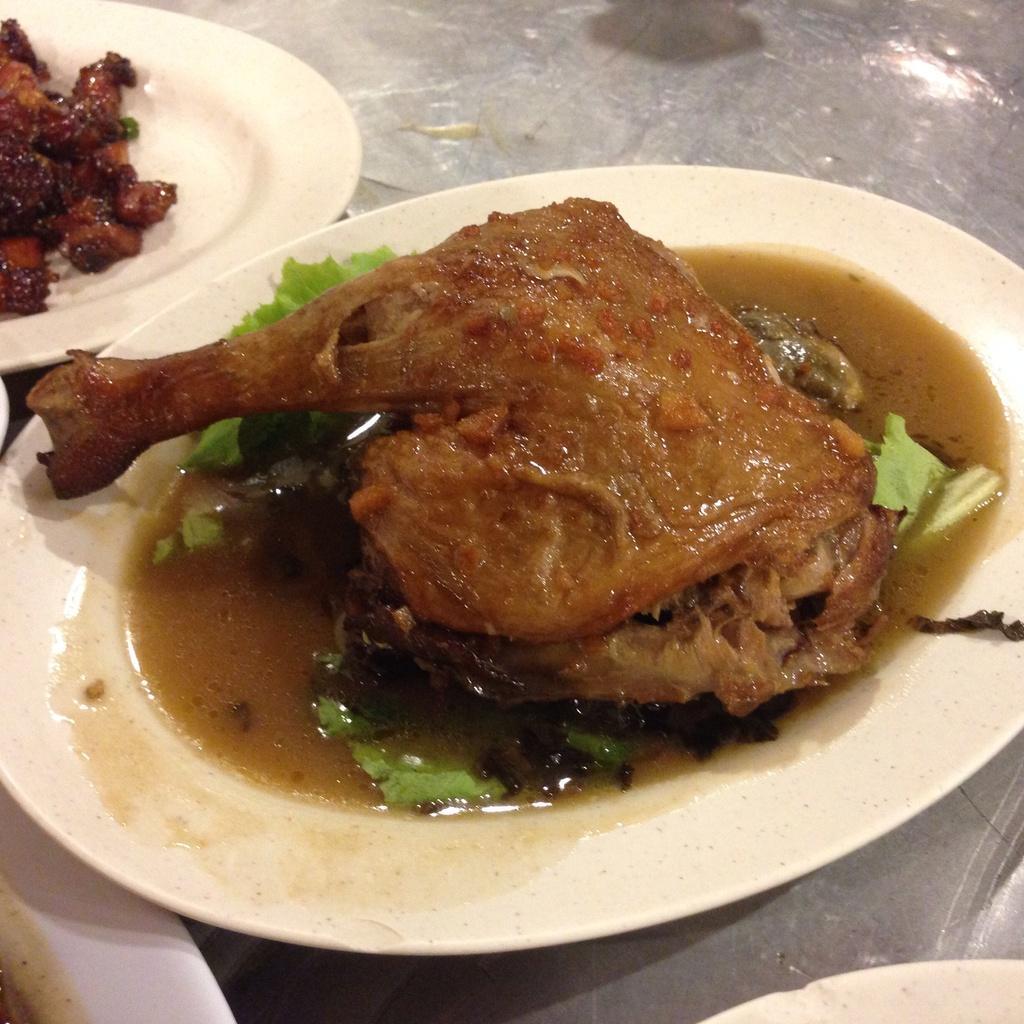Please provide a concise description of this image. In this image we can see plates. On the plates there are food items. And the plates are on a surface. 